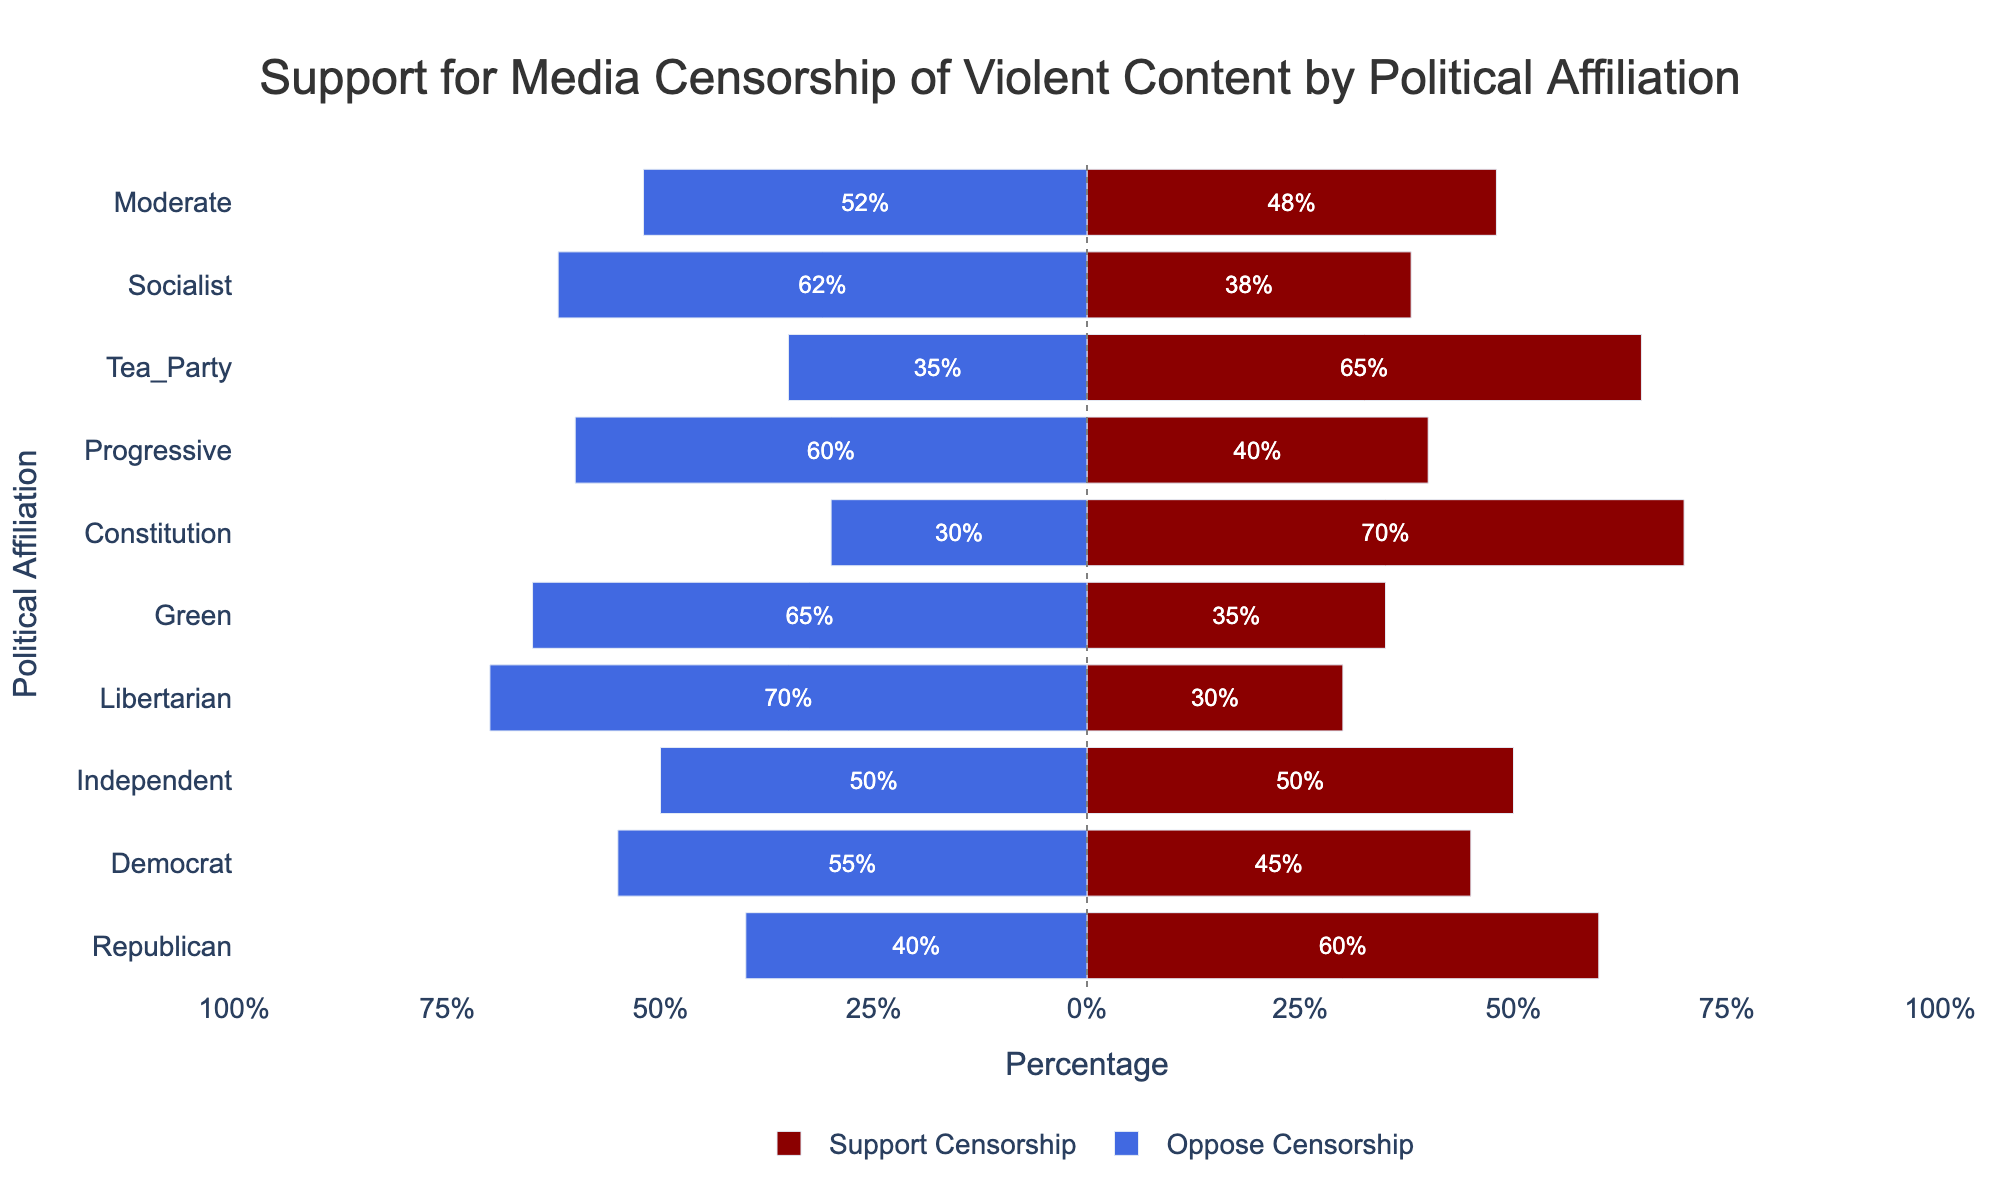Which political affiliation has the highest support for media censorship of violent content? The figure shows different political affiliations on the y-axis and their support for censorship percentages on the x-axis. The Republican affiliation has the longest red bar extending to 60%.
Answer: Republican Which political affiliation has the lowest support for media censorship of violent content? The Libertarian affiliation has the shortest red bar, extending to 30%, which is the lowest support for censorship.
Answer: Libertarian How many political affiliations have more than 50% support for media censorship? By visually counting the red bars that extend beyond the 50% mark, we find that there are three such affiliations: Republican, Tea Party, and Constitution.
Answer: 3 What is the difference in support for media censorship between Republicans and Libertarians? Republicans have 60% support for censorship, while Libertarians have 30%. The difference is 60% - 30% = 30%.
Answer: 30% Do more political affiliations support or oppose media censorship of violent content? By comparing the number of red and blue bars, we see that most political affiliations have longer blue bars, indicating opposition. Specifically, 7 affiliations oppose it, while 3 support it more.
Answer: Oppose Which two political affiliations have the closest levels of support for media censorship? By visually inspecting the length of the red bars, the Progressive and Socialist affiliations have close support levels, with 40% and 38% respectively.
Answer: Progressive and Socialist What is the average support for media censorship across all political affiliations? Summing up the support percentages (60 + 45 + 50 + 30 + 35 + 70 + 40 + 65 + 38 + 48) gives 481. Dividing by the number of affiliations (10) gives an average of 48.1%.
Answer: 48.1% Which political affiliation has an equal number of supporters and opposers? The Independent affiliation has a red bar at 50% and a blue bar at -50%, showing equal support and opposition.
Answer: Independent 